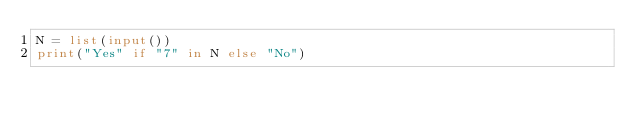<code> <loc_0><loc_0><loc_500><loc_500><_Python_>N = list(input())
print("Yes" if "7" in N else "No")</code> 